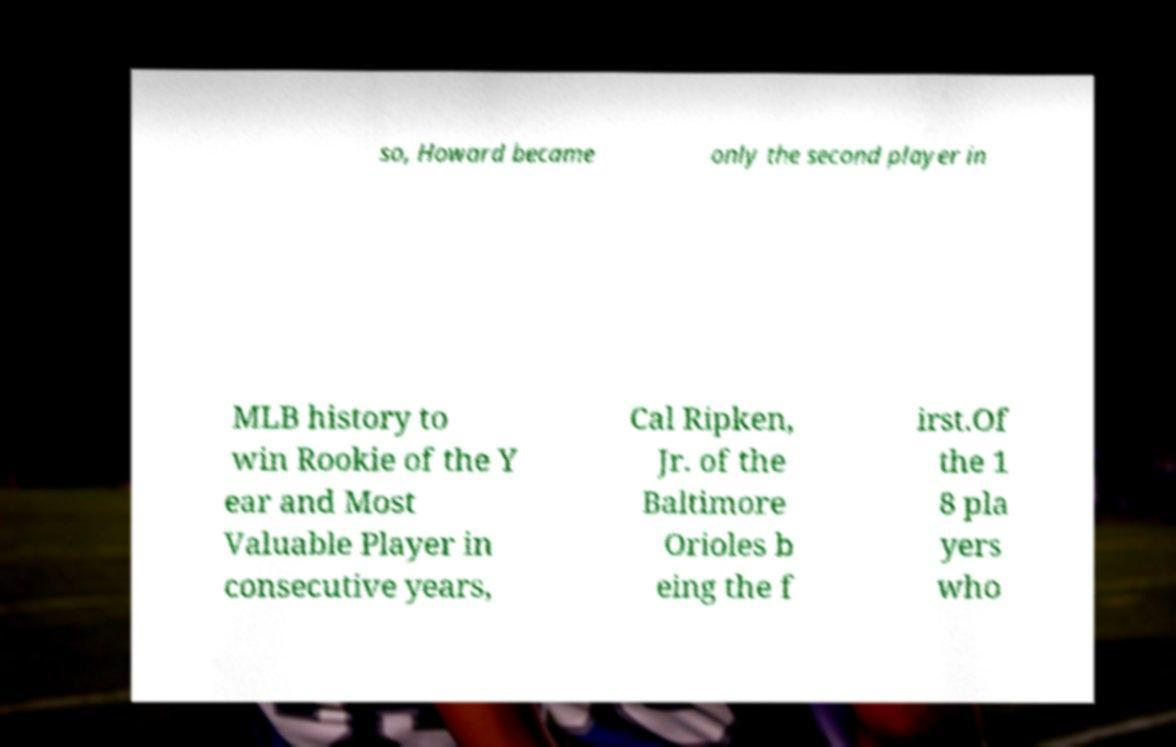Can you accurately transcribe the text from the provided image for me? so, Howard became only the second player in MLB history to win Rookie of the Y ear and Most Valuable Player in consecutive years, Cal Ripken, Jr. of the Baltimore Orioles b eing the f irst.Of the 1 8 pla yers who 